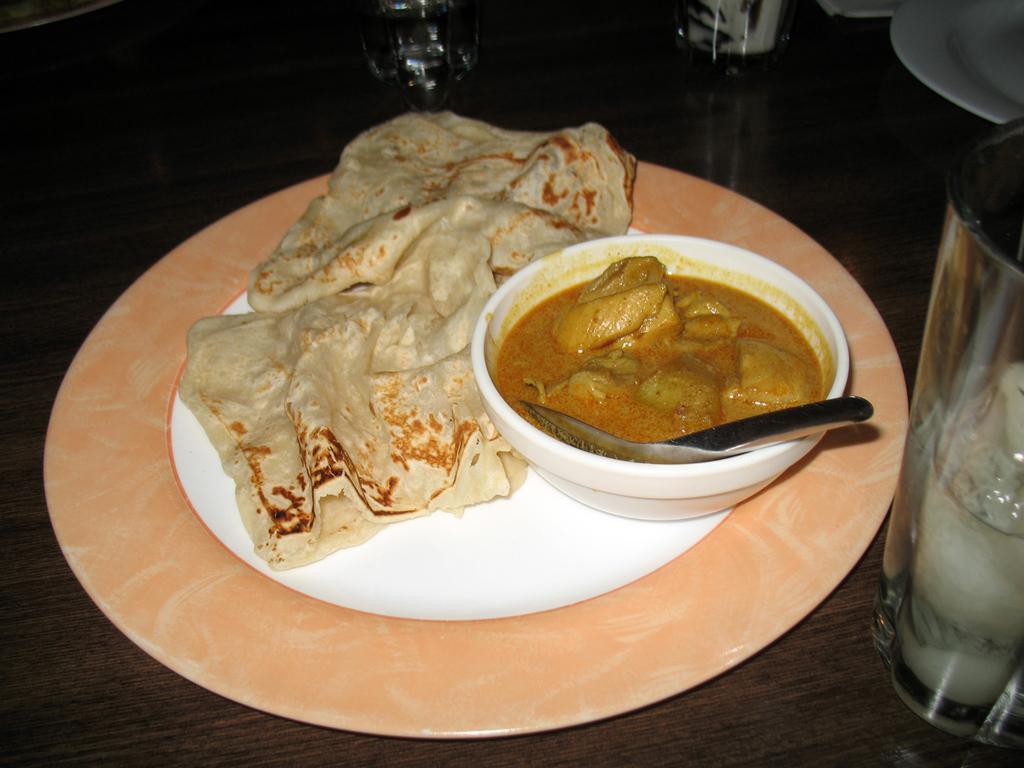Can you describe this image briefly? In this picture I can see food items on the plate and in the bowl with a spoon, there are glasses and some other objects on the table. 